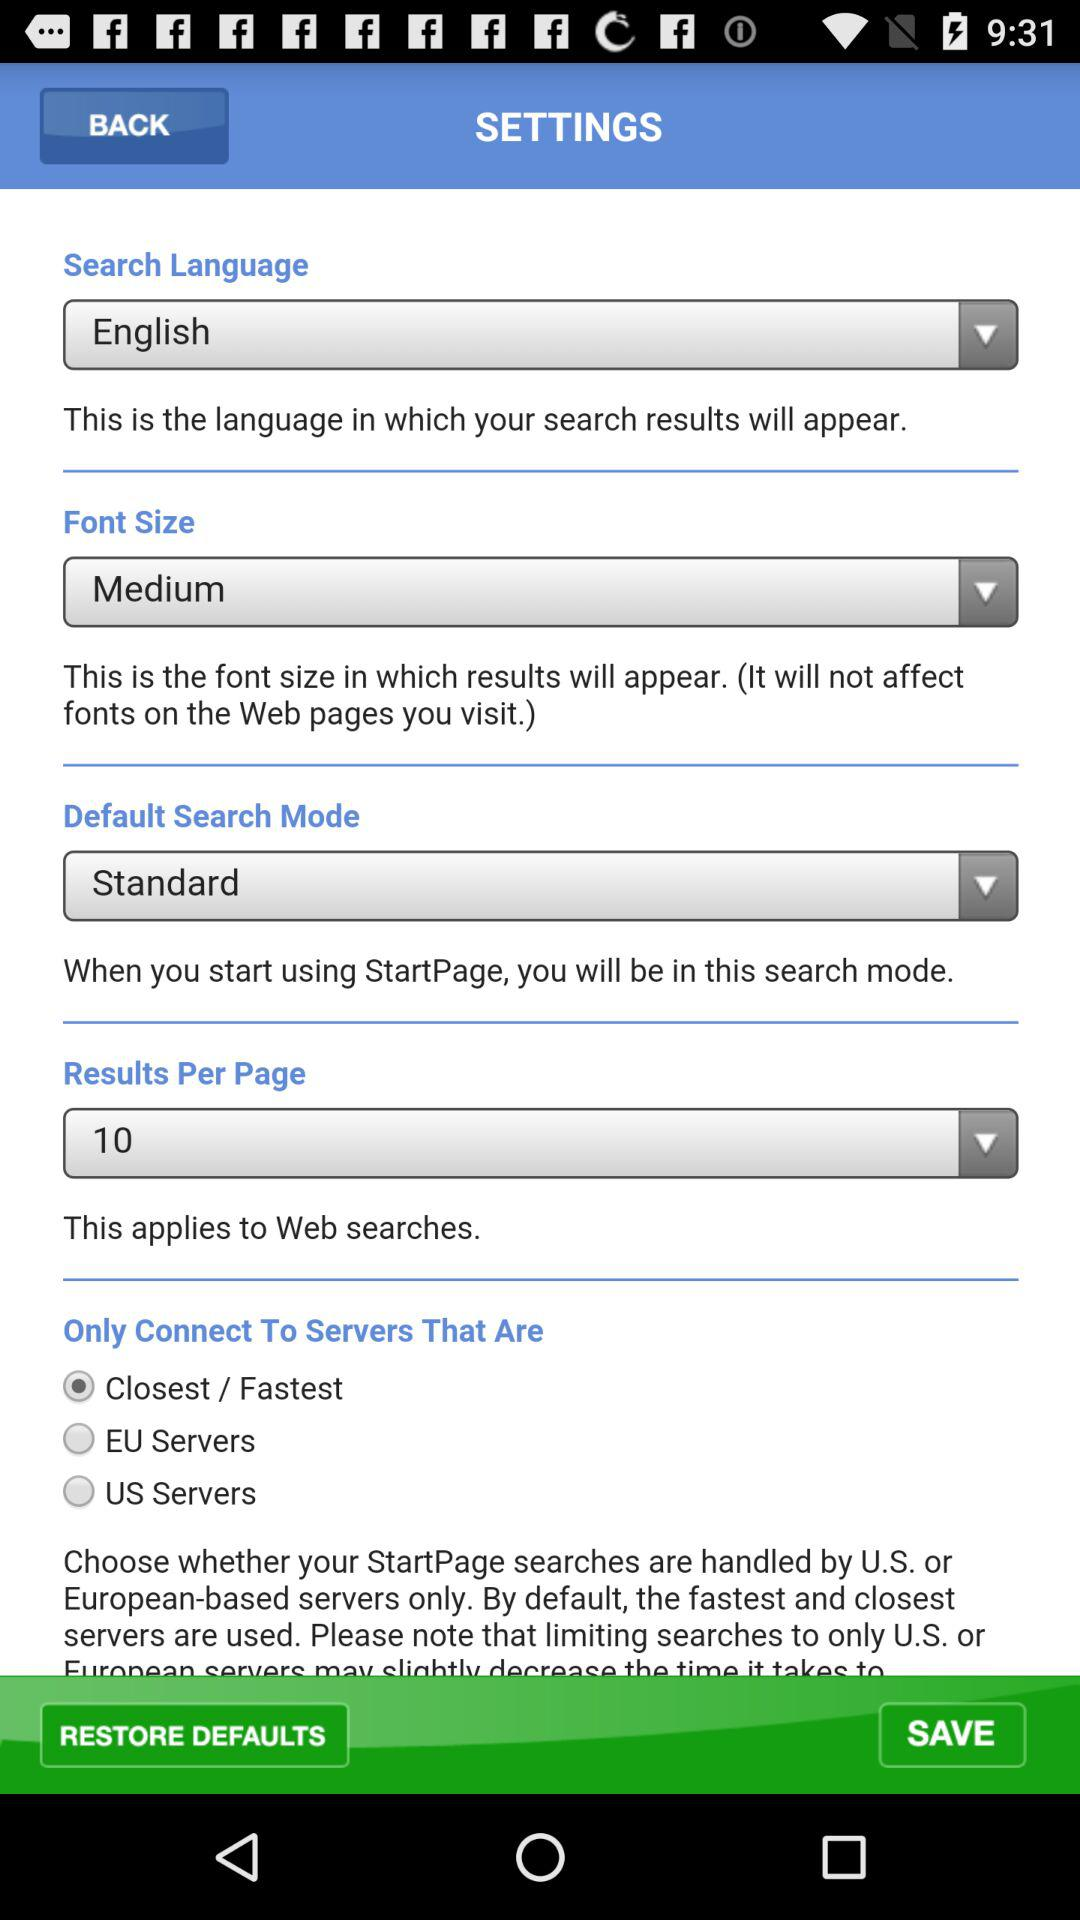What is the font size? The font size is "Medium". 